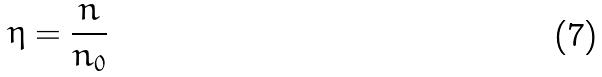<formula> <loc_0><loc_0><loc_500><loc_500>\eta = \frac { n } { n _ { 0 } }</formula> 